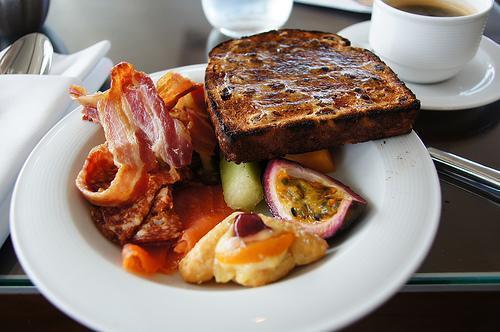How many food items are on the plate?
Give a very brief answer. 8. How many empty plates are there?
Give a very brief answer. 0. 